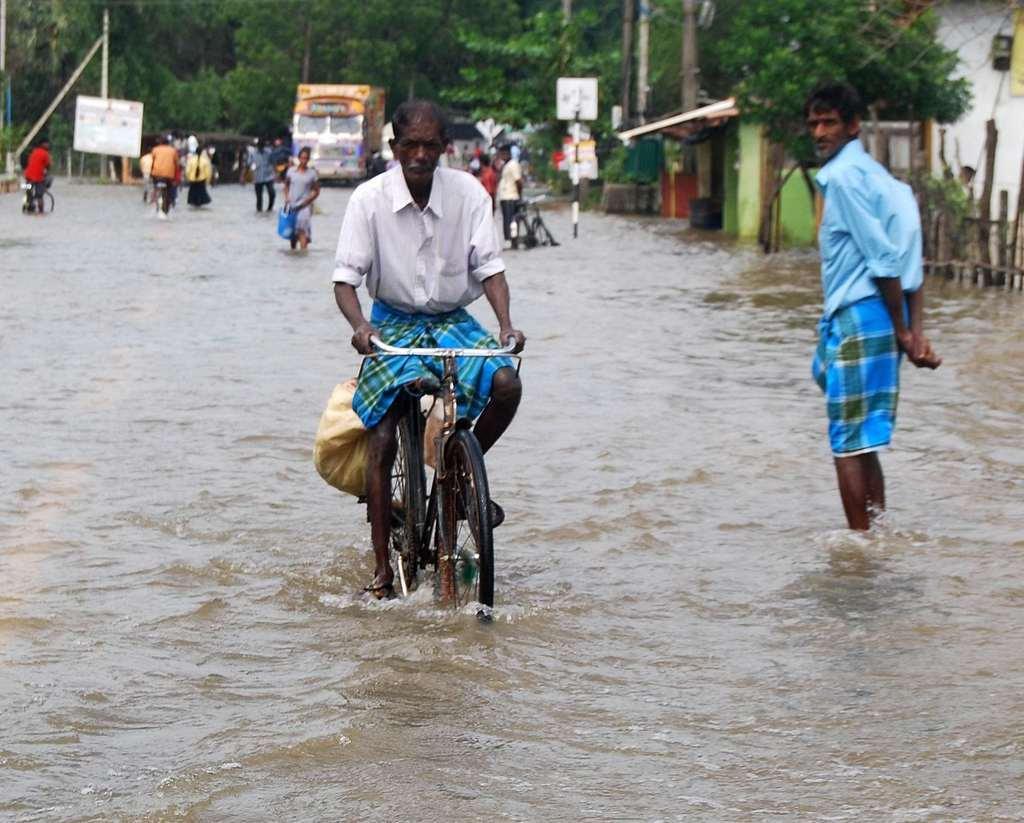Can you describe this image briefly? The person wearing a white shirt is riding a bicycle on a water filled road and the wearing blue shirt is standing beside him and there are group of people and Heavy vehicles and green trees in the background, There is also a light green colored house on the right side 